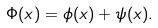Convert formula to latex. <formula><loc_0><loc_0><loc_500><loc_500>\Phi ( x ) = \phi ( x ) + \psi ( x ) .</formula> 